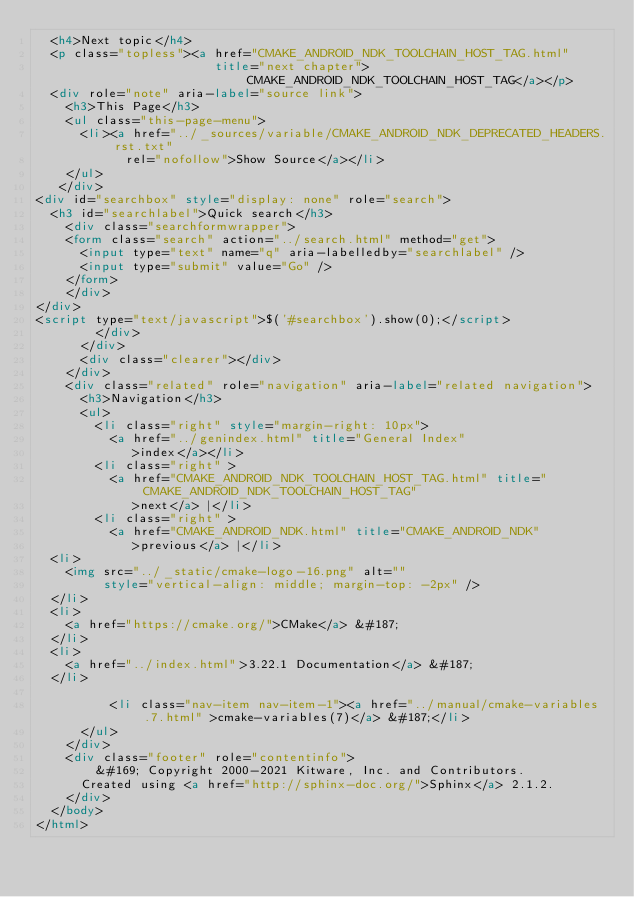Convert code to text. <code><loc_0><loc_0><loc_500><loc_500><_HTML_>  <h4>Next topic</h4>
  <p class="topless"><a href="CMAKE_ANDROID_NDK_TOOLCHAIN_HOST_TAG.html"
                        title="next chapter">CMAKE_ANDROID_NDK_TOOLCHAIN_HOST_TAG</a></p>
  <div role="note" aria-label="source link">
    <h3>This Page</h3>
    <ul class="this-page-menu">
      <li><a href="../_sources/variable/CMAKE_ANDROID_NDK_DEPRECATED_HEADERS.rst.txt"
            rel="nofollow">Show Source</a></li>
    </ul>
   </div>
<div id="searchbox" style="display: none" role="search">
  <h3 id="searchlabel">Quick search</h3>
    <div class="searchformwrapper">
    <form class="search" action="../search.html" method="get">
      <input type="text" name="q" aria-labelledby="searchlabel" />
      <input type="submit" value="Go" />
    </form>
    </div>
</div>
<script type="text/javascript">$('#searchbox').show(0);</script>
        </div>
      </div>
      <div class="clearer"></div>
    </div>
    <div class="related" role="navigation" aria-label="related navigation">
      <h3>Navigation</h3>
      <ul>
        <li class="right" style="margin-right: 10px">
          <a href="../genindex.html" title="General Index"
             >index</a></li>
        <li class="right" >
          <a href="CMAKE_ANDROID_NDK_TOOLCHAIN_HOST_TAG.html" title="CMAKE_ANDROID_NDK_TOOLCHAIN_HOST_TAG"
             >next</a> |</li>
        <li class="right" >
          <a href="CMAKE_ANDROID_NDK.html" title="CMAKE_ANDROID_NDK"
             >previous</a> |</li>
  <li>
    <img src="../_static/cmake-logo-16.png" alt=""
         style="vertical-align: middle; margin-top: -2px" />
  </li>
  <li>
    <a href="https://cmake.org/">CMake</a> &#187;
  </li>
  <li>
    <a href="../index.html">3.22.1 Documentation</a> &#187;
  </li>

          <li class="nav-item nav-item-1"><a href="../manual/cmake-variables.7.html" >cmake-variables(7)</a> &#187;</li> 
      </ul>
    </div>
    <div class="footer" role="contentinfo">
        &#169; Copyright 2000-2021 Kitware, Inc. and Contributors.
      Created using <a href="http://sphinx-doc.org/">Sphinx</a> 2.1.2.
    </div>
  </body>
</html></code> 